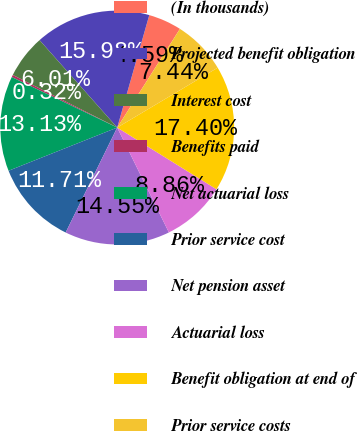<chart> <loc_0><loc_0><loc_500><loc_500><pie_chart><fcel>(In thousands)<fcel>Projected benefit obligation<fcel>Interest cost<fcel>Benefits paid<fcel>Net actuarial loss<fcel>Prior service cost<fcel>Net pension asset<fcel>Actuarial loss<fcel>Benefit obligation at end of<fcel>Prior service costs<nl><fcel>4.59%<fcel>15.98%<fcel>6.01%<fcel>0.32%<fcel>13.13%<fcel>11.71%<fcel>14.55%<fcel>8.86%<fcel>17.4%<fcel>7.44%<nl></chart> 